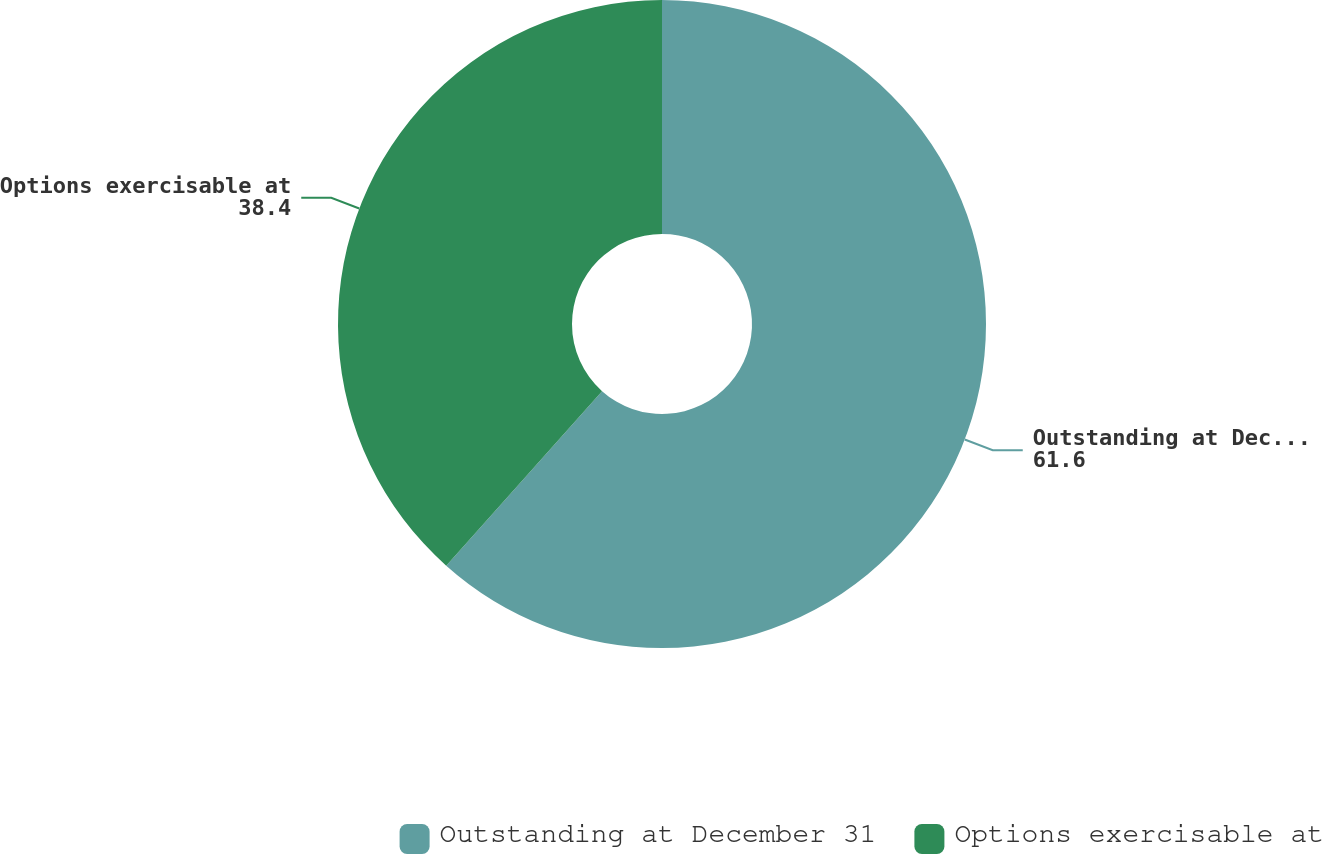Convert chart to OTSL. <chart><loc_0><loc_0><loc_500><loc_500><pie_chart><fcel>Outstanding at December 31<fcel>Options exercisable at<nl><fcel>61.6%<fcel>38.4%<nl></chart> 